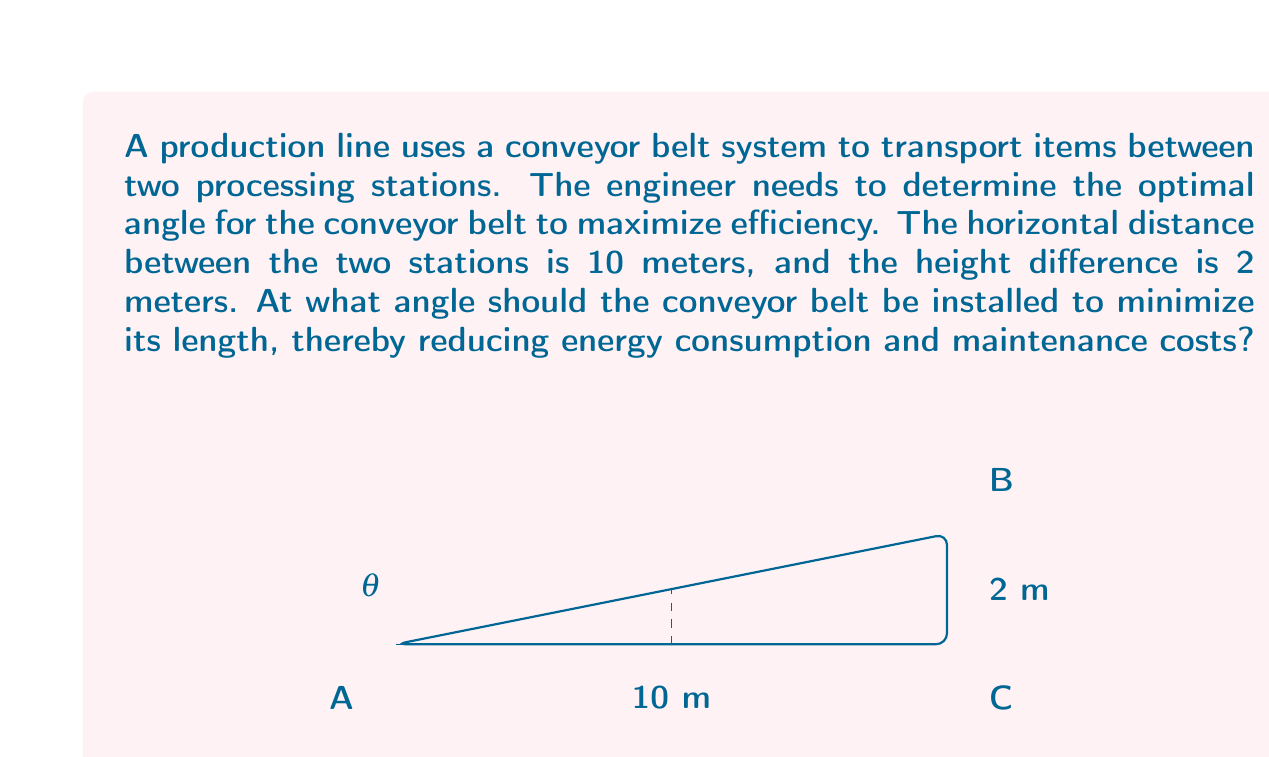Could you help me with this problem? To solve this problem, we need to use trigonometry to find the angle that minimizes the length of the conveyor belt. The conveyor belt forms the hypotenuse of a right triangle, where the horizontal distance is the base and the height difference is the opposite side.

Let's approach this step-by-step:

1) First, we need to express the length of the conveyor belt (L) in terms of the angle $\theta$:

   $$L = \frac{10}{\cos\theta}$$

2) We know that $\tan\theta = \frac{\text{opposite}}{\text{adjacent}} = \frac{2}{10} = 0.2$

3) To find the angle that minimizes L, we need to find $\theta$ such that $\tan\theta = 0.2$

4) We can use the inverse tangent (arctan) function:

   $$\theta = \arctan(0.2)$$

5) Using a calculator or computer, we can find:

   $$\theta \approx 11.31^\circ$$

This angle will provide the shortest possible length for the conveyor belt, thus maximizing efficiency by minimizing energy consumption and maintenance costs.

To verify, we can calculate the length of the conveyor belt:

$$L = \sqrt{10^2 + 2^2} \approx 10.20 \text{ meters}$$

This is indeed the shortest possible path between the two points.
Answer: The optimal angle for the conveyor belt is approximately $11.31^\circ$ from the horizontal. 